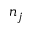<formula> <loc_0><loc_0><loc_500><loc_500>n _ { j }</formula> 